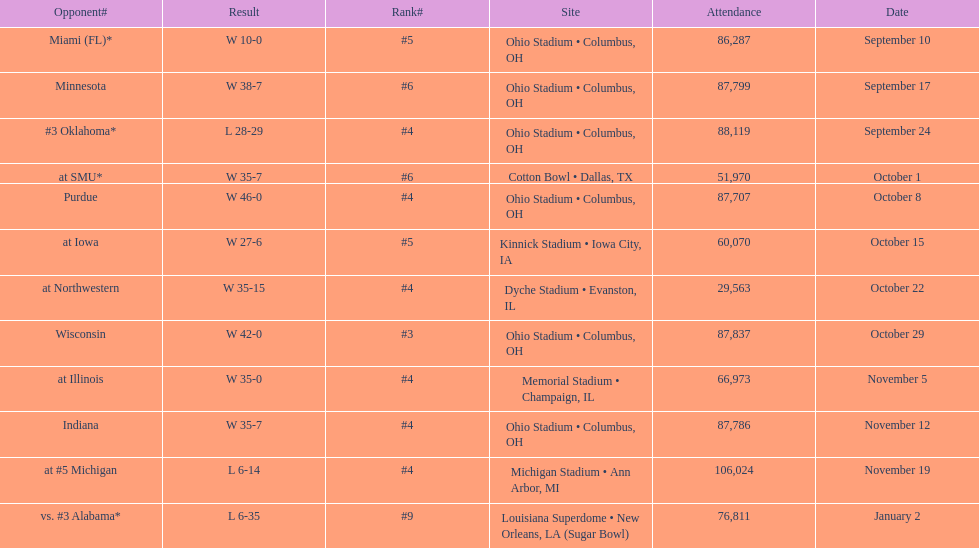Can you parse all the data within this table? {'header': ['Opponent#', 'Result', 'Rank#', 'Site', 'Attendance', 'Date'], 'rows': [['Miami (FL)*', 'W\xa010-0', '#5', 'Ohio Stadium • Columbus, OH', '86,287', 'September 10'], ['Minnesota', 'W\xa038-7', '#6', 'Ohio Stadium • Columbus, OH', '87,799', 'September 17'], ['#3\xa0Oklahoma*', 'L\xa028-29', '#4', 'Ohio Stadium • Columbus, OH', '88,119', 'September 24'], ['at\xa0SMU*', 'W\xa035-7', '#6', 'Cotton Bowl • Dallas, TX', '51,970', 'October 1'], ['Purdue', 'W\xa046-0', '#4', 'Ohio Stadium • Columbus, OH', '87,707', 'October 8'], ['at\xa0Iowa', 'W\xa027-6', '#5', 'Kinnick Stadium • Iowa City, IA', '60,070', 'October 15'], ['at\xa0Northwestern', 'W\xa035-15', '#4', 'Dyche Stadium • Evanston, IL', '29,563', 'October 22'], ['Wisconsin', 'W\xa042-0', '#3', 'Ohio Stadium • Columbus, OH', '87,837', 'October 29'], ['at\xa0Illinois', 'W\xa035-0', '#4', 'Memorial Stadium • Champaign, IL', '66,973', 'November 5'], ['Indiana', 'W\xa035-7', '#4', 'Ohio Stadium • Columbus, OH', '87,786', 'November 12'], ['at\xa0#5\xa0Michigan', 'L\xa06-14', '#4', 'Michigan Stadium • Ann Arbor, MI', '106,024', 'November 19'], ['vs.\xa0#3\xa0Alabama*', 'L\xa06-35', '#9', 'Louisiana Superdome • New Orleans, LA (Sugar Bowl)', '76,811', 'January 2']]} How many dates are on the chart 12. 